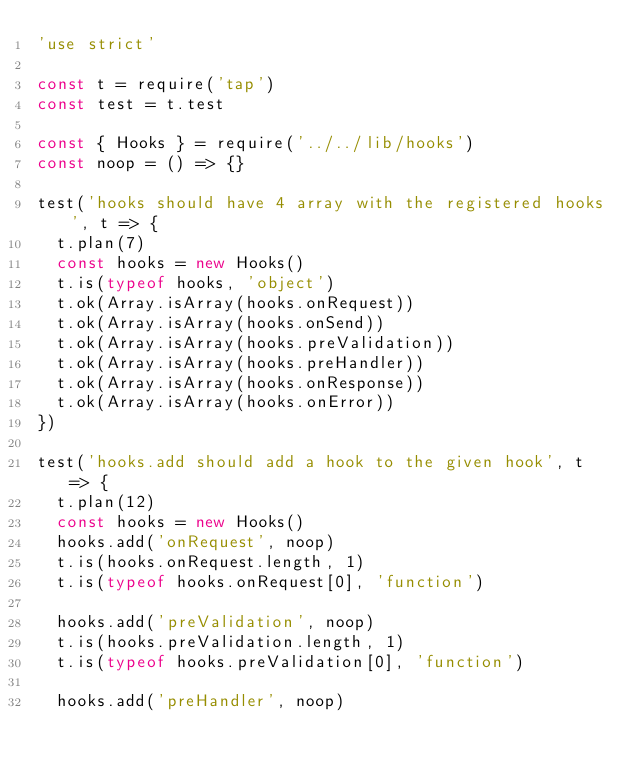Convert code to text. <code><loc_0><loc_0><loc_500><loc_500><_JavaScript_>'use strict'

const t = require('tap')
const test = t.test

const { Hooks } = require('../../lib/hooks')
const noop = () => {}

test('hooks should have 4 array with the registered hooks', t => {
  t.plan(7)
  const hooks = new Hooks()
  t.is(typeof hooks, 'object')
  t.ok(Array.isArray(hooks.onRequest))
  t.ok(Array.isArray(hooks.onSend))
  t.ok(Array.isArray(hooks.preValidation))
  t.ok(Array.isArray(hooks.preHandler))
  t.ok(Array.isArray(hooks.onResponse))
  t.ok(Array.isArray(hooks.onError))
})

test('hooks.add should add a hook to the given hook', t => {
  t.plan(12)
  const hooks = new Hooks()
  hooks.add('onRequest', noop)
  t.is(hooks.onRequest.length, 1)
  t.is(typeof hooks.onRequest[0], 'function')

  hooks.add('preValidation', noop)
  t.is(hooks.preValidation.length, 1)
  t.is(typeof hooks.preValidation[0], 'function')

  hooks.add('preHandler', noop)</code> 